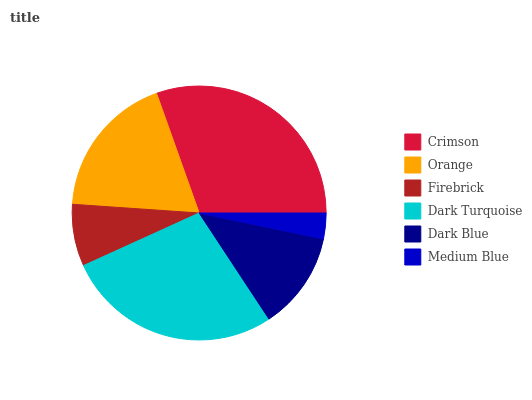Is Medium Blue the minimum?
Answer yes or no. Yes. Is Crimson the maximum?
Answer yes or no. Yes. Is Orange the minimum?
Answer yes or no. No. Is Orange the maximum?
Answer yes or no. No. Is Crimson greater than Orange?
Answer yes or no. Yes. Is Orange less than Crimson?
Answer yes or no. Yes. Is Orange greater than Crimson?
Answer yes or no. No. Is Crimson less than Orange?
Answer yes or no. No. Is Orange the high median?
Answer yes or no. Yes. Is Dark Blue the low median?
Answer yes or no. Yes. Is Crimson the high median?
Answer yes or no. No. Is Dark Turquoise the low median?
Answer yes or no. No. 